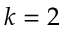Convert formula to latex. <formula><loc_0><loc_0><loc_500><loc_500>k = 2</formula> 